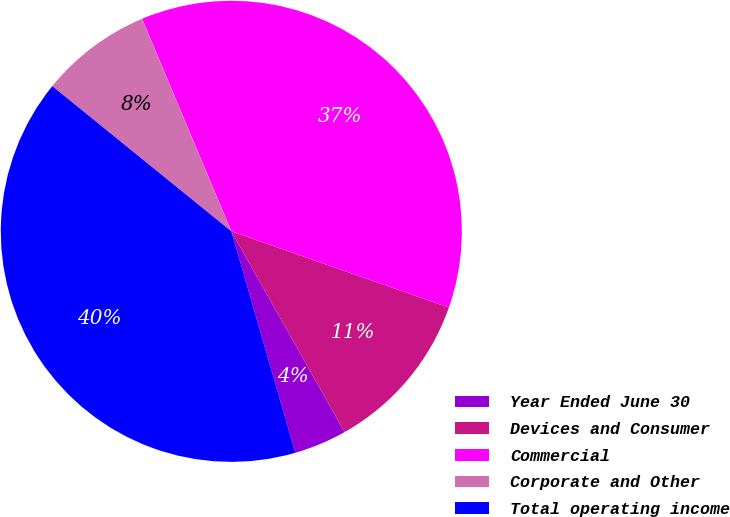<chart> <loc_0><loc_0><loc_500><loc_500><pie_chart><fcel>Year Ended June 30<fcel>Devices and Consumer<fcel>Commercial<fcel>Corporate and Other<fcel>Total operating income<nl><fcel>3.7%<fcel>11.46%<fcel>36.69%<fcel>7.83%<fcel>40.32%<nl></chart> 